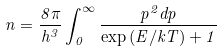<formula> <loc_0><loc_0><loc_500><loc_500>n = \frac { 8 \pi } { h ^ { 3 } } \int _ { 0 } ^ { \infty } \frac { p ^ { 2 } d p } { \exp { ( E / k T ) } + 1 }</formula> 